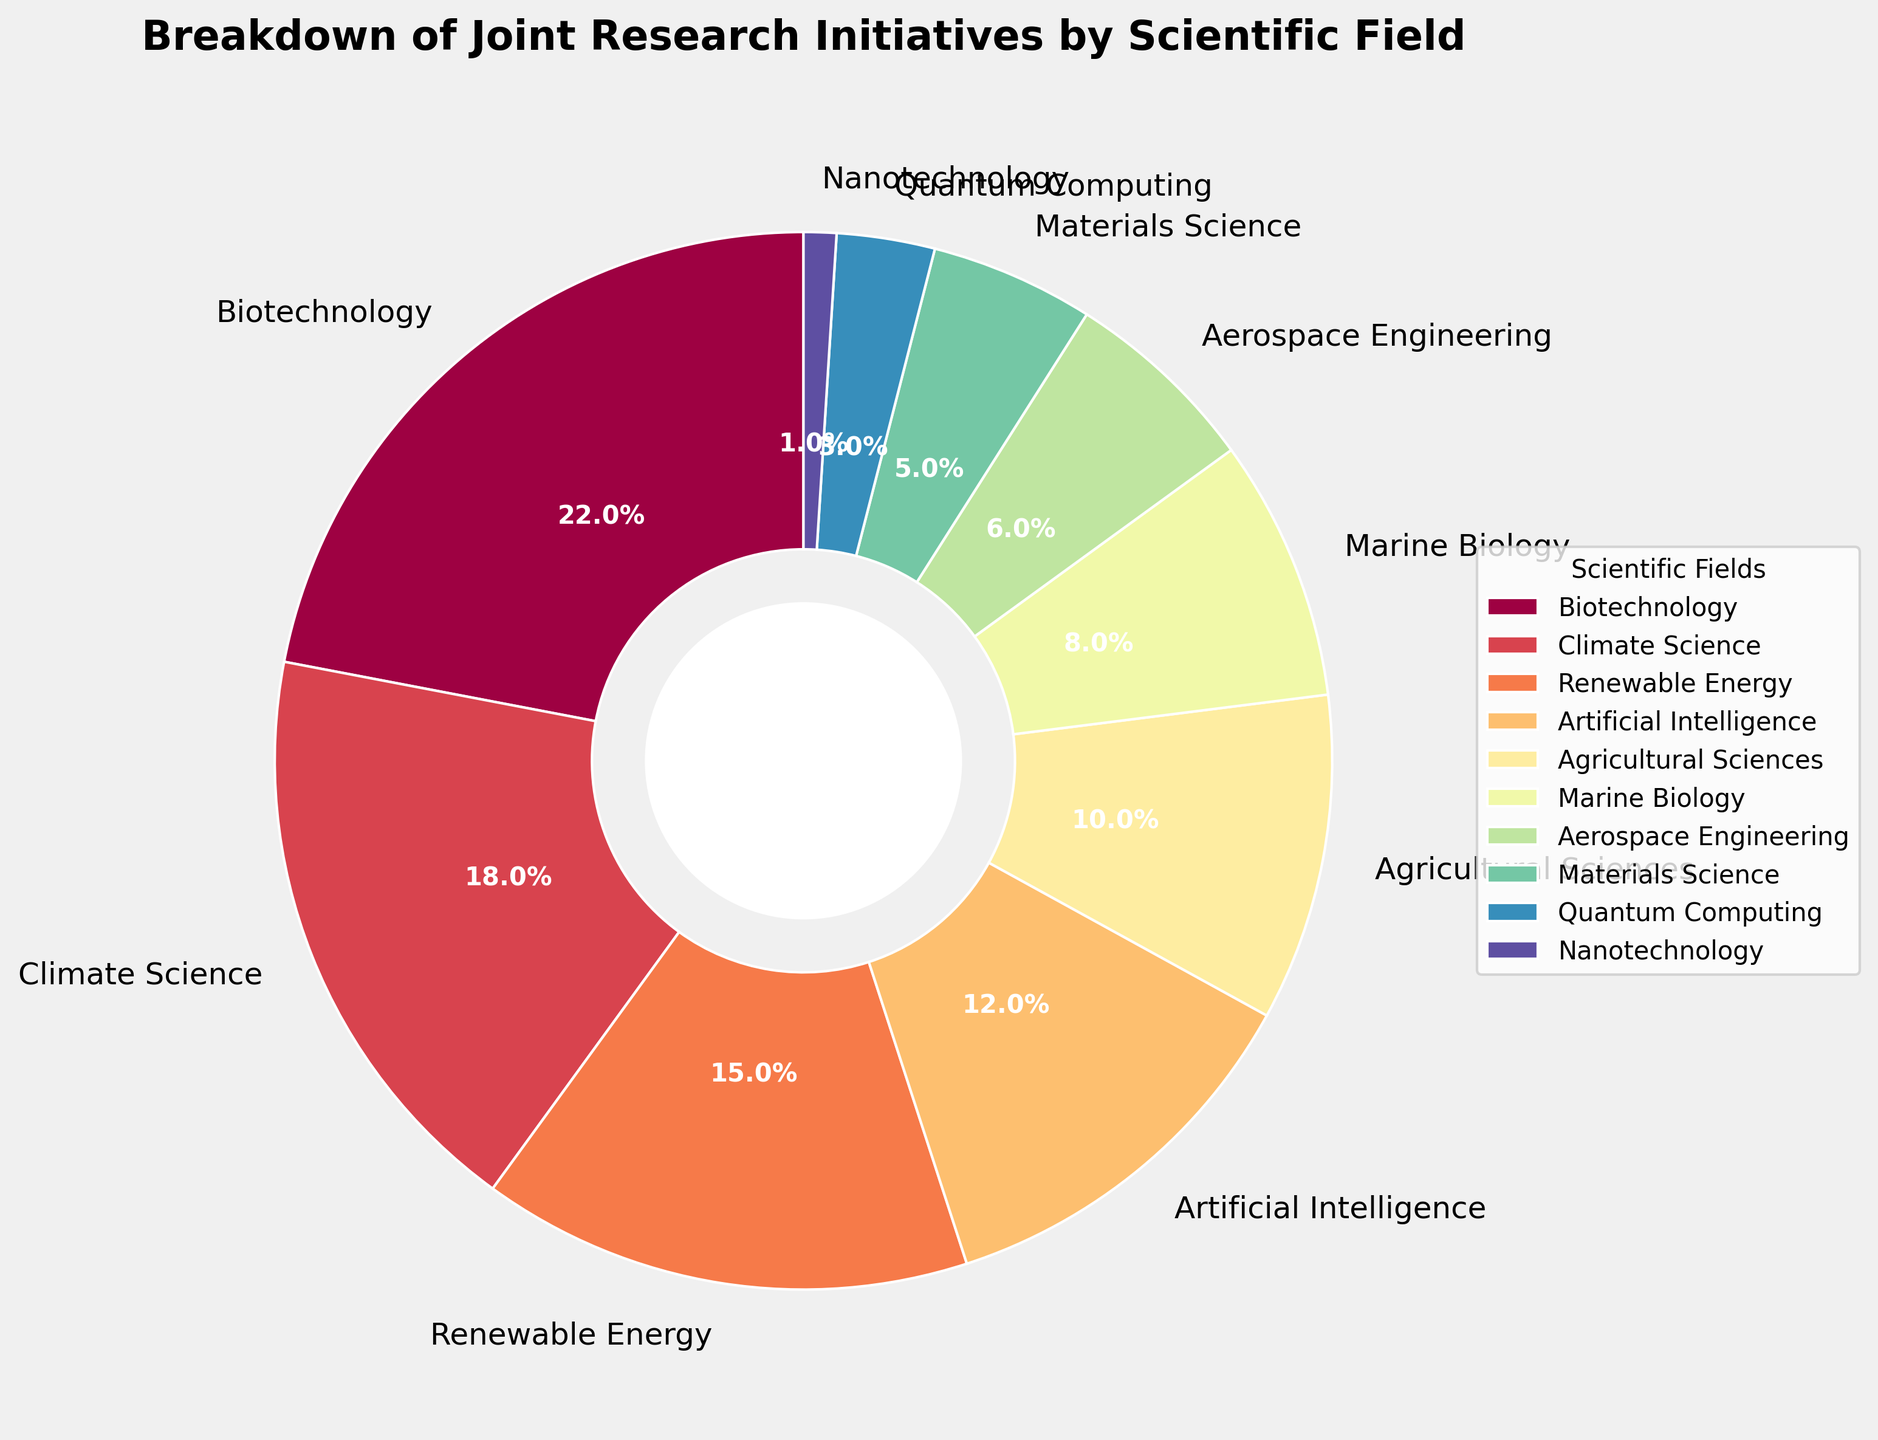Which scientific field has the highest percentage of joint research initiatives? The pie chart shows several scientific fields with their corresponding percentages. By identifying the sector with the largest size, we can see that Biotechnology has the highest percentage.
Answer: Biotechnology How much higher is the percentage of initiatives in Biotechnology compared to Artificial Intelligence? Biotechnology is 22% and Artificial Intelligence is 12%. The difference is calculated by subtracting the percentage of AI from that of Biotechnology, i.e., 22% - 12% = 10%.
Answer: 10% Which fields have a lower percentage of research initiatives than Maritime Biology? Marine Biology has a percentage of 8%. Fields with lower percentages are Aerospace Engineering (6%), Materials Science (5%), Quantum Computing (3%), and Nanotechnology (1%).
Answer: Aerospace Engineering, Materials Science, Quantum Computing, Nanotechnology Calculate the combined percentage of research initiatives in Renewable Energy and Climate Science. Renewable Energy is 15% and Climate Science is 18%. Adding these two percentages together gives 15% + 18% = 33%.
Answer: 33% Is the percentage of Agricultural Sciences higher than or equal to the combined percentage of Nanotechnology and Quantum Computing? Agricultural Sciences is 10%. The combined percentage for Nanotechnology and Quantum Computing is 1% + 3% = 4%. Comparing these, 10% is higher than 4%.
Answer: Yes What is the difference in percentage between the field with the most initiatives and the field with the least initiatives? The field with the most initiatives is Biotechnology at 22%, and the field with the least initiatives is Nanotechnology at 1%. The difference is calculated by subtracting 1% from 22%, which is 22% - 1% = 21%.
Answer: 21% What field corresponds to the smallest color sector in the pie chart? The smallest sector visually represents the smallest percentage, which is Nanotechnology at 1%.
Answer: Nanotechnology How many fields have a percentage of 10% or more? Fields with a percentage of 10% or more are Biotechnology (22%), Climate Science (18%), Renewable Energy (15%), Artificial Intelligence (12%), and Agricultural Sciences (10%). Counting these fields gives 5.
Answer: 5 